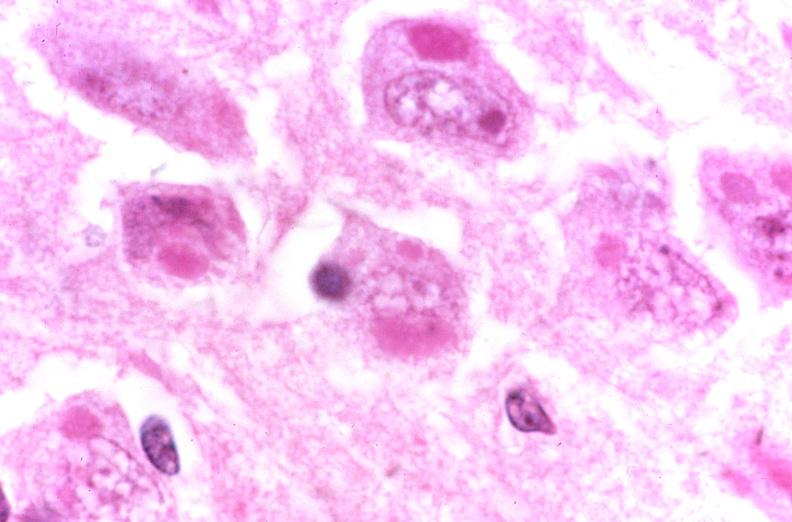what is present?
Answer the question using a single word or phrase. Nervous 